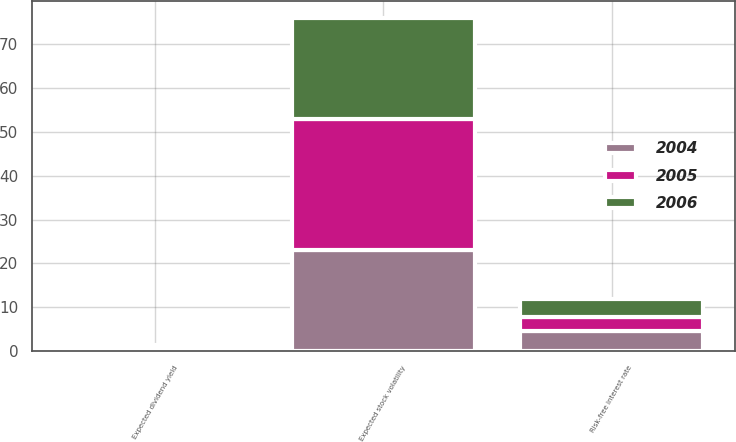Convert chart to OTSL. <chart><loc_0><loc_0><loc_500><loc_500><stacked_bar_chart><ecel><fcel>Expected dividend yield<fcel>Expected stock volatility<fcel>Risk-free interest rate<nl><fcel>2004<fcel>0.44<fcel>23<fcel>4.59<nl><fcel>2006<fcel>0.52<fcel>23<fcel>4.07<nl><fcel>2005<fcel>0.46<fcel>30<fcel>3.24<nl></chart> 